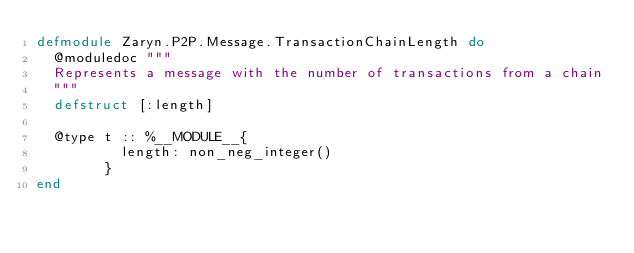<code> <loc_0><loc_0><loc_500><loc_500><_Elixir_>defmodule Zaryn.P2P.Message.TransactionChainLength do
  @moduledoc """
  Represents a message with the number of transactions from a chain
  """
  defstruct [:length]

  @type t :: %__MODULE__{
          length: non_neg_integer()
        }
end
</code> 